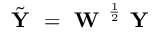Convert formula to latex. <formula><loc_0><loc_0><loc_500><loc_500>\tilde { Y } = W ^ { \frac { 1 } { 2 } } Y</formula> 